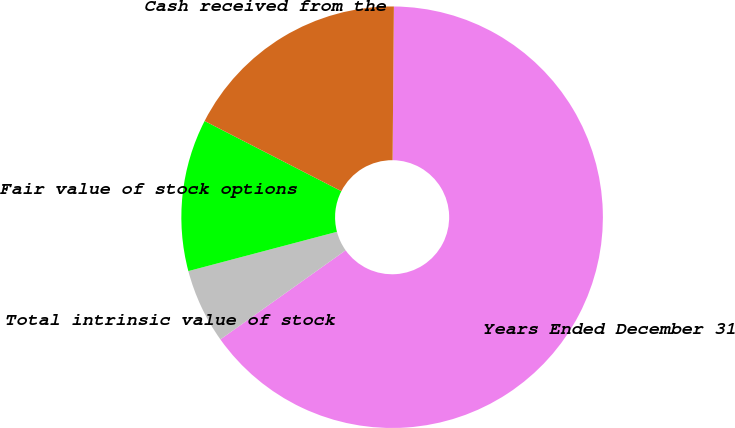<chart> <loc_0><loc_0><loc_500><loc_500><pie_chart><fcel>Years Ended December 31<fcel>Total intrinsic value of stock<fcel>Fair value of stock options<fcel>Cash received from the<nl><fcel>65.03%<fcel>5.73%<fcel>11.66%<fcel>17.59%<nl></chart> 